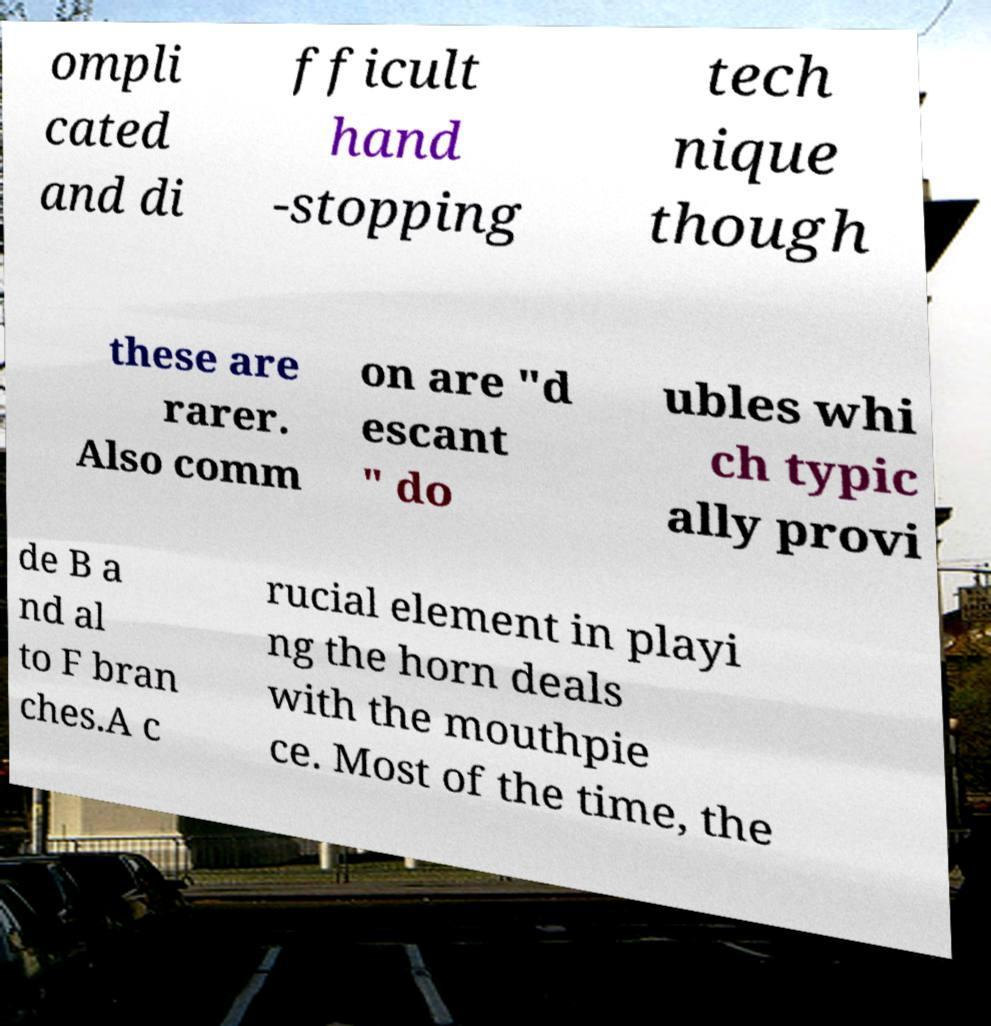What messages or text are displayed in this image? I need them in a readable, typed format. ompli cated and di fficult hand -stopping tech nique though these are rarer. Also comm on are "d escant " do ubles whi ch typic ally provi de B a nd al to F bran ches.A c rucial element in playi ng the horn deals with the mouthpie ce. Most of the time, the 